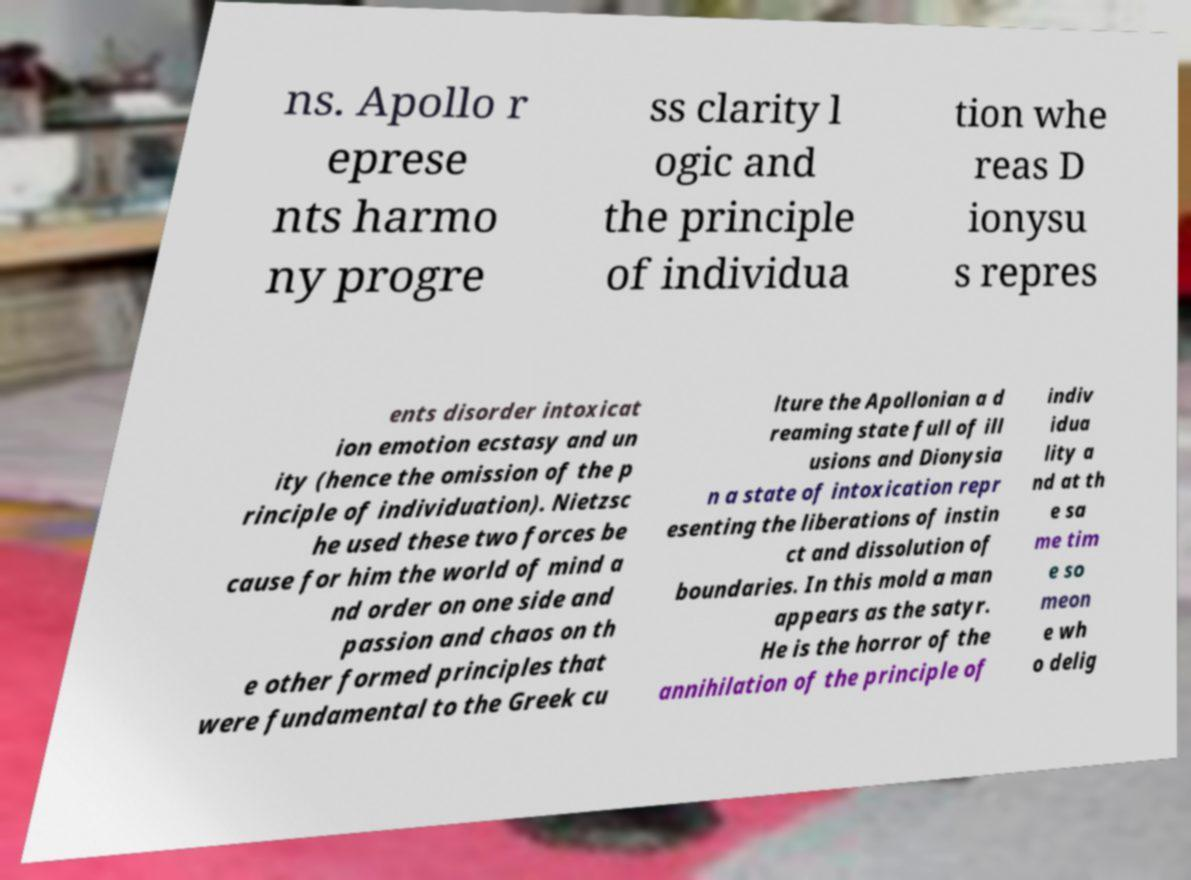Can you read and provide the text displayed in the image?This photo seems to have some interesting text. Can you extract and type it out for me? ns. Apollo r eprese nts harmo ny progre ss clarity l ogic and the principle of individua tion whe reas D ionysu s repres ents disorder intoxicat ion emotion ecstasy and un ity (hence the omission of the p rinciple of individuation). Nietzsc he used these two forces be cause for him the world of mind a nd order on one side and passion and chaos on th e other formed principles that were fundamental to the Greek cu lture the Apollonian a d reaming state full of ill usions and Dionysia n a state of intoxication repr esenting the liberations of instin ct and dissolution of boundaries. In this mold a man appears as the satyr. He is the horror of the annihilation of the principle of indiv idua lity a nd at th e sa me tim e so meon e wh o delig 